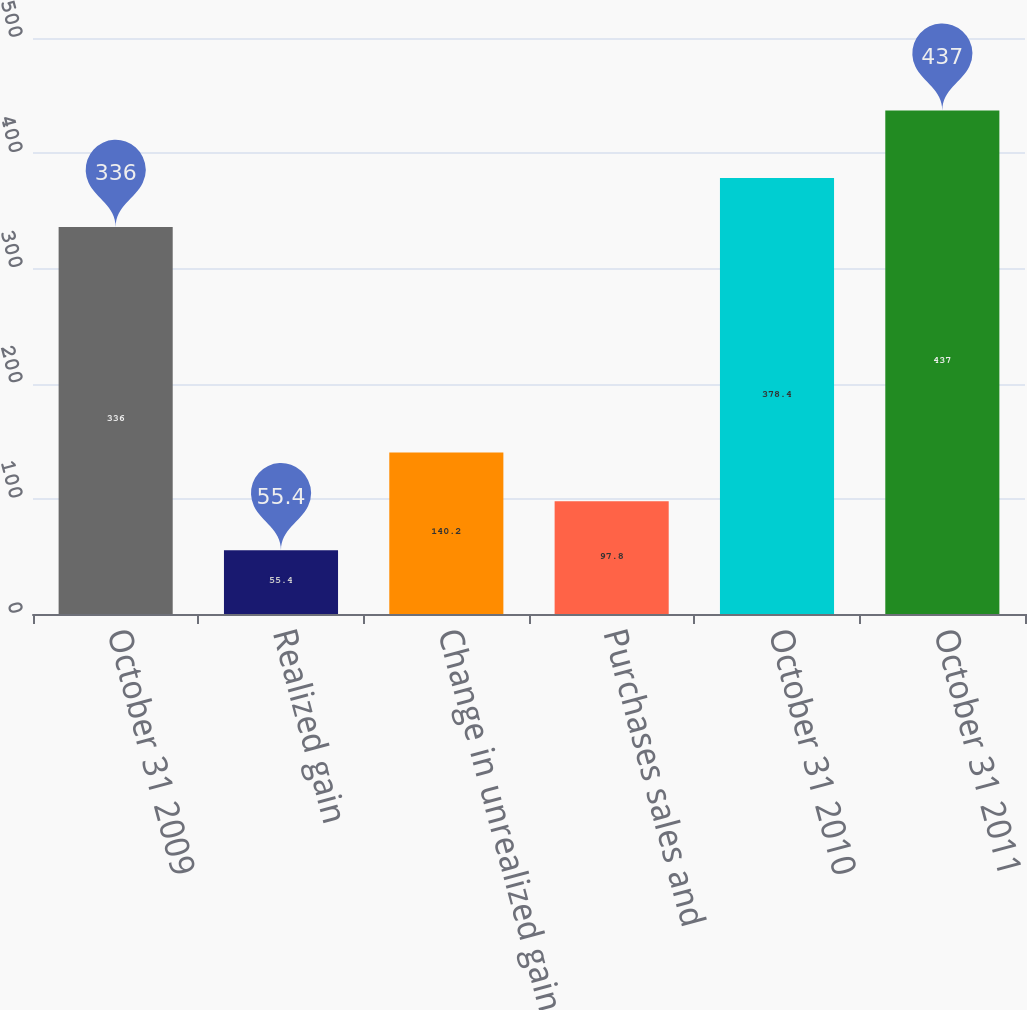Convert chart to OTSL. <chart><loc_0><loc_0><loc_500><loc_500><bar_chart><fcel>October 31 2009<fcel>Realized gain<fcel>Change in unrealized gain<fcel>Purchases sales and<fcel>October 31 2010<fcel>October 31 2011<nl><fcel>336<fcel>55.4<fcel>140.2<fcel>97.8<fcel>378.4<fcel>437<nl></chart> 